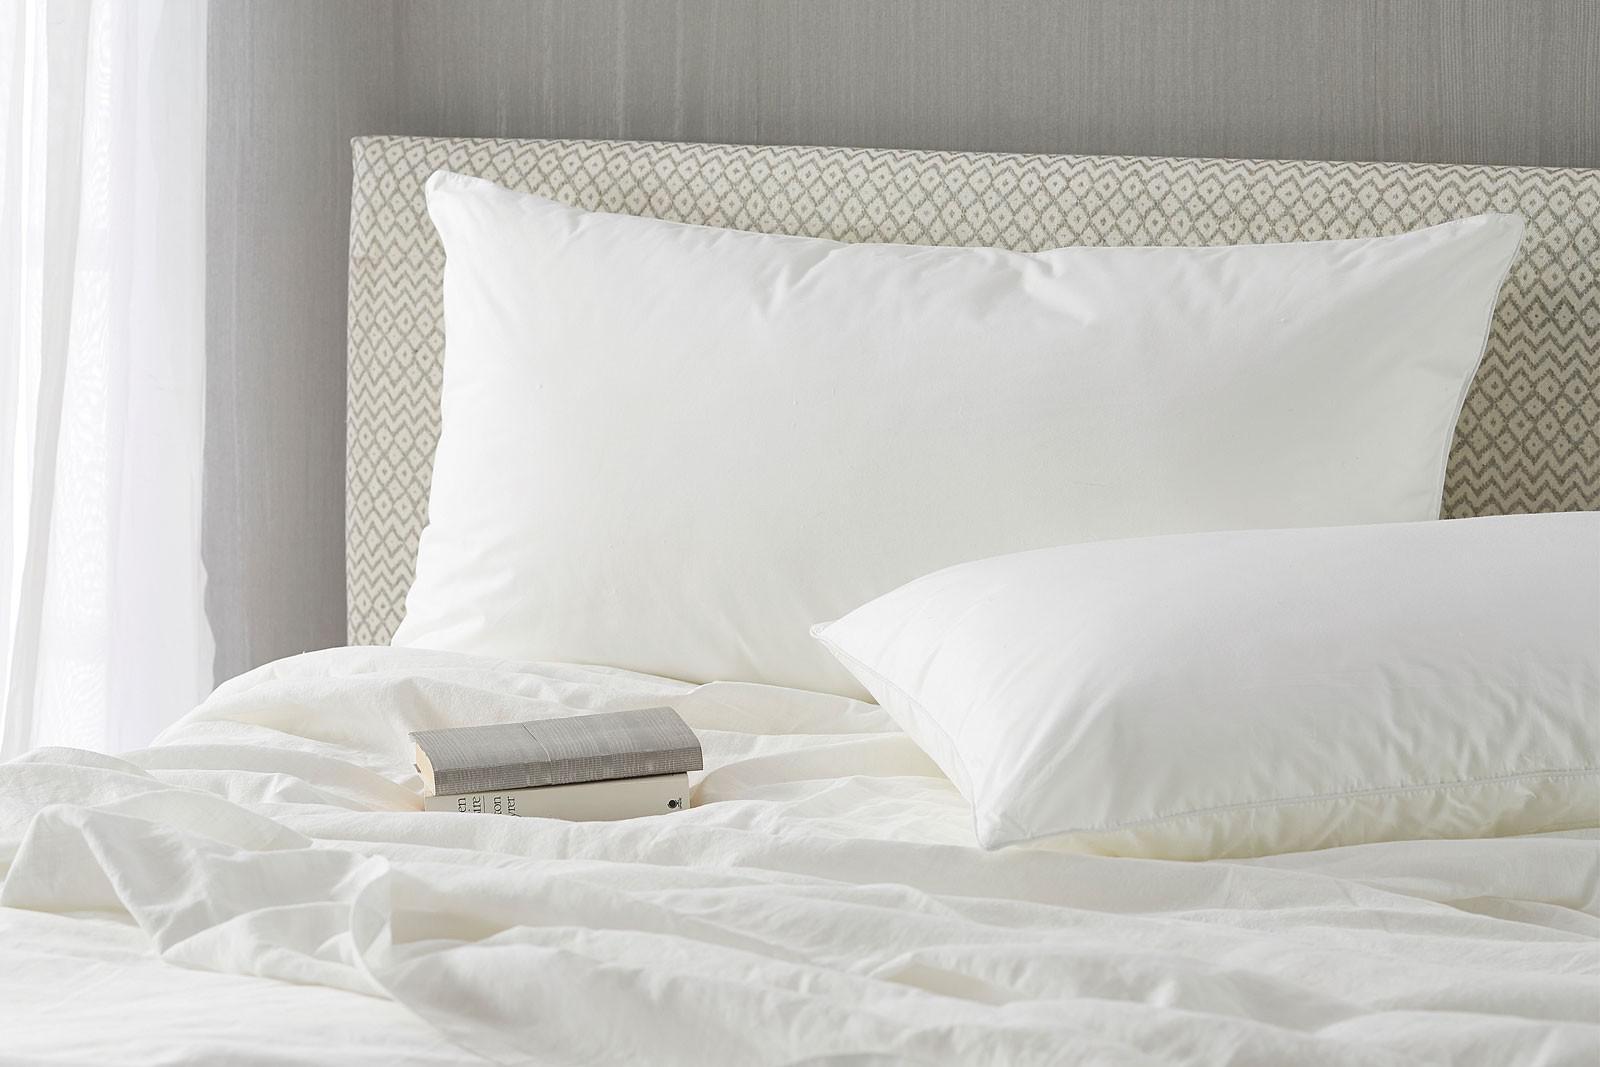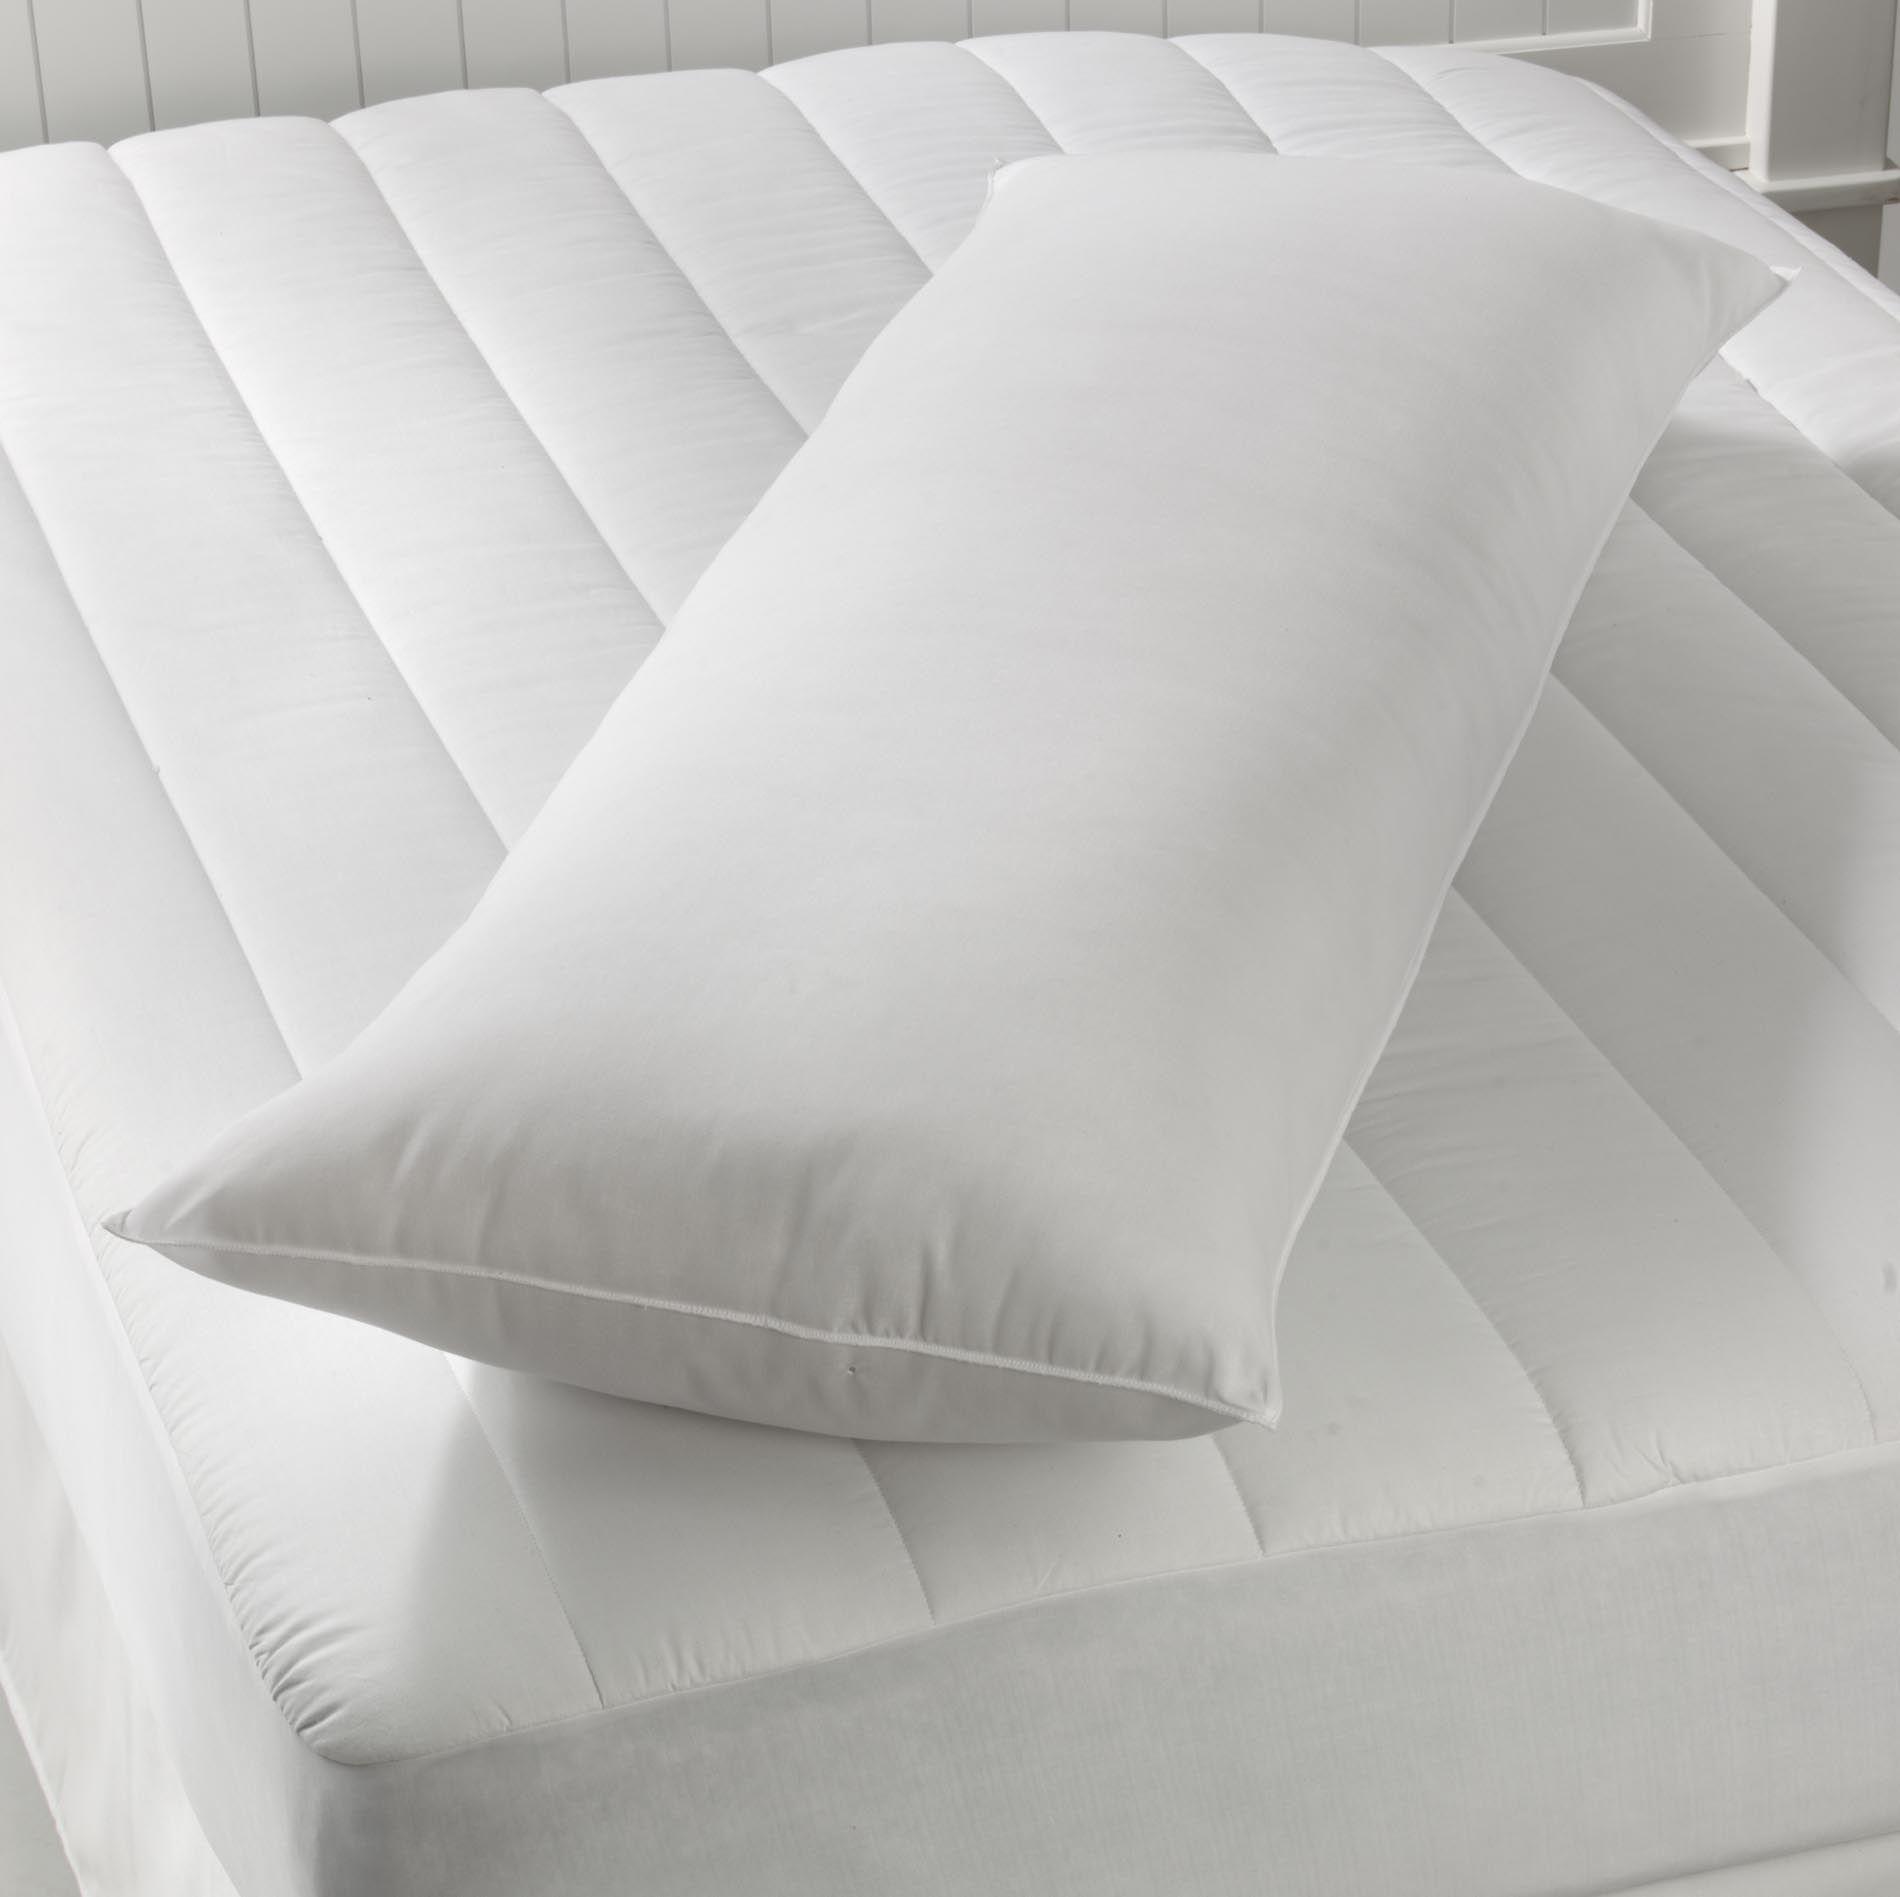The first image is the image on the left, the second image is the image on the right. For the images displayed, is the sentence "Every photo features less than four white pillows all displayed inside a home." factually correct? Answer yes or no. Yes. 